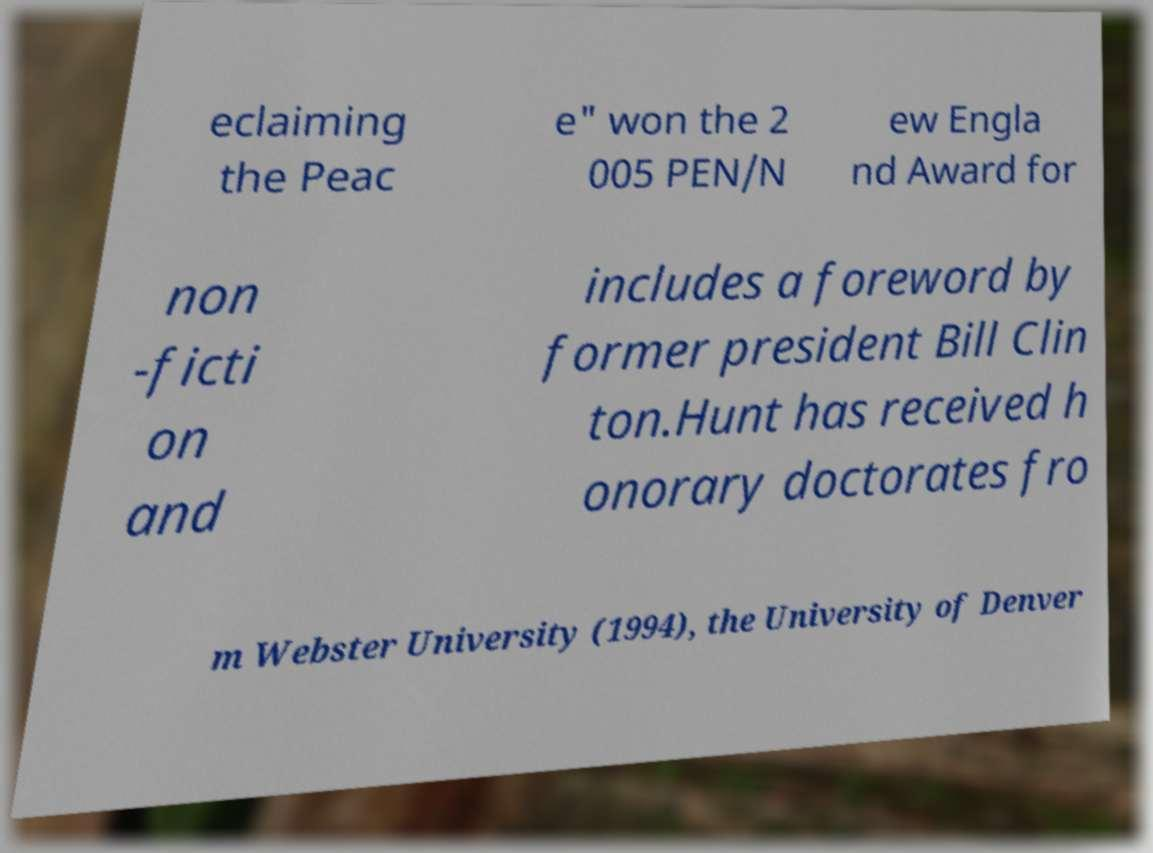Could you assist in decoding the text presented in this image and type it out clearly? eclaiming the Peac e" won the 2 005 PEN/N ew Engla nd Award for non -ficti on and includes a foreword by former president Bill Clin ton.Hunt has received h onorary doctorates fro m Webster University (1994), the University of Denver 